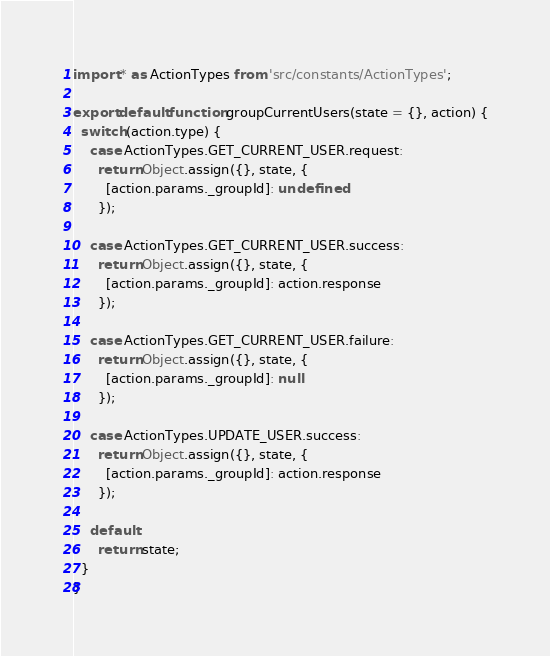<code> <loc_0><loc_0><loc_500><loc_500><_JavaScript_>import * as ActionTypes from 'src/constants/ActionTypes';

export default function groupCurrentUsers(state = {}, action) {
  switch (action.type) {
    case ActionTypes.GET_CURRENT_USER.request:
      return Object.assign({}, state, {
        [action.params._groupId]: undefined
      });

    case ActionTypes.GET_CURRENT_USER.success:
      return Object.assign({}, state, {
        [action.params._groupId]: action.response
      });

    case ActionTypes.GET_CURRENT_USER.failure:
      return Object.assign({}, state, {
        [action.params._groupId]: null
      });

    case ActionTypes.UPDATE_USER.success:
      return Object.assign({}, state, {
        [action.params._groupId]: action.response
      });

    default:
      return state;
  }
}
</code> 